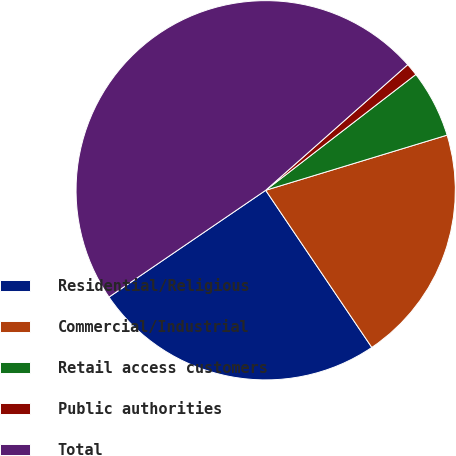Convert chart. <chart><loc_0><loc_0><loc_500><loc_500><pie_chart><fcel>Residential/Religious<fcel>Commercial/Industrial<fcel>Retail access customers<fcel>Public authorities<fcel>Total<nl><fcel>24.93%<fcel>20.24%<fcel>5.76%<fcel>1.07%<fcel>47.99%<nl></chart> 